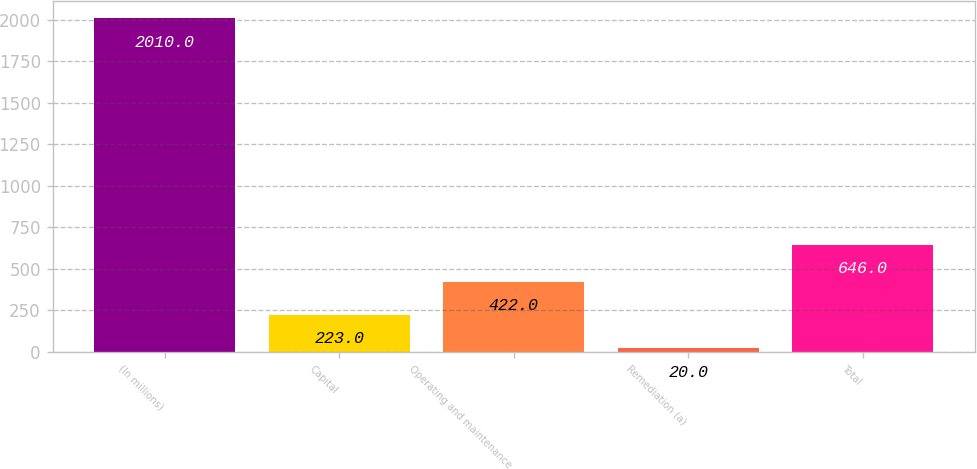Convert chart. <chart><loc_0><loc_0><loc_500><loc_500><bar_chart><fcel>(In millions)<fcel>Capital<fcel>Operating and maintenance<fcel>Remediation (a)<fcel>Total<nl><fcel>2010<fcel>223<fcel>422<fcel>20<fcel>646<nl></chart> 